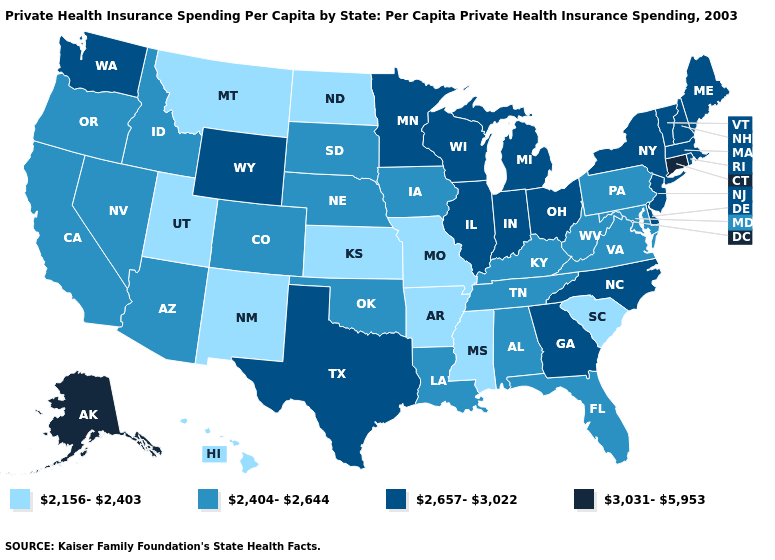What is the value of Washington?
Concise answer only. 2,657-3,022. Among the states that border Missouri , does Kansas have the lowest value?
Short answer required. Yes. Does New York have a lower value than Connecticut?
Answer briefly. Yes. What is the value of Pennsylvania?
Quick response, please. 2,404-2,644. Name the states that have a value in the range 2,404-2,644?
Answer briefly. Alabama, Arizona, California, Colorado, Florida, Idaho, Iowa, Kentucky, Louisiana, Maryland, Nebraska, Nevada, Oklahoma, Oregon, Pennsylvania, South Dakota, Tennessee, Virginia, West Virginia. Which states have the lowest value in the Northeast?
Give a very brief answer. Pennsylvania. Which states have the lowest value in the West?
Short answer required. Hawaii, Montana, New Mexico, Utah. What is the value of New Mexico?
Answer briefly. 2,156-2,403. Does Wisconsin have the same value as Louisiana?
Quick response, please. No. What is the value of Montana?
Write a very short answer. 2,156-2,403. Does Mississippi have the lowest value in the South?
Keep it brief. Yes. What is the lowest value in the USA?
Concise answer only. 2,156-2,403. Among the states that border Kansas , which have the lowest value?
Give a very brief answer. Missouri. Which states have the lowest value in the USA?
Quick response, please. Arkansas, Hawaii, Kansas, Mississippi, Missouri, Montana, New Mexico, North Dakota, South Carolina, Utah. Does California have the lowest value in the USA?
Keep it brief. No. 